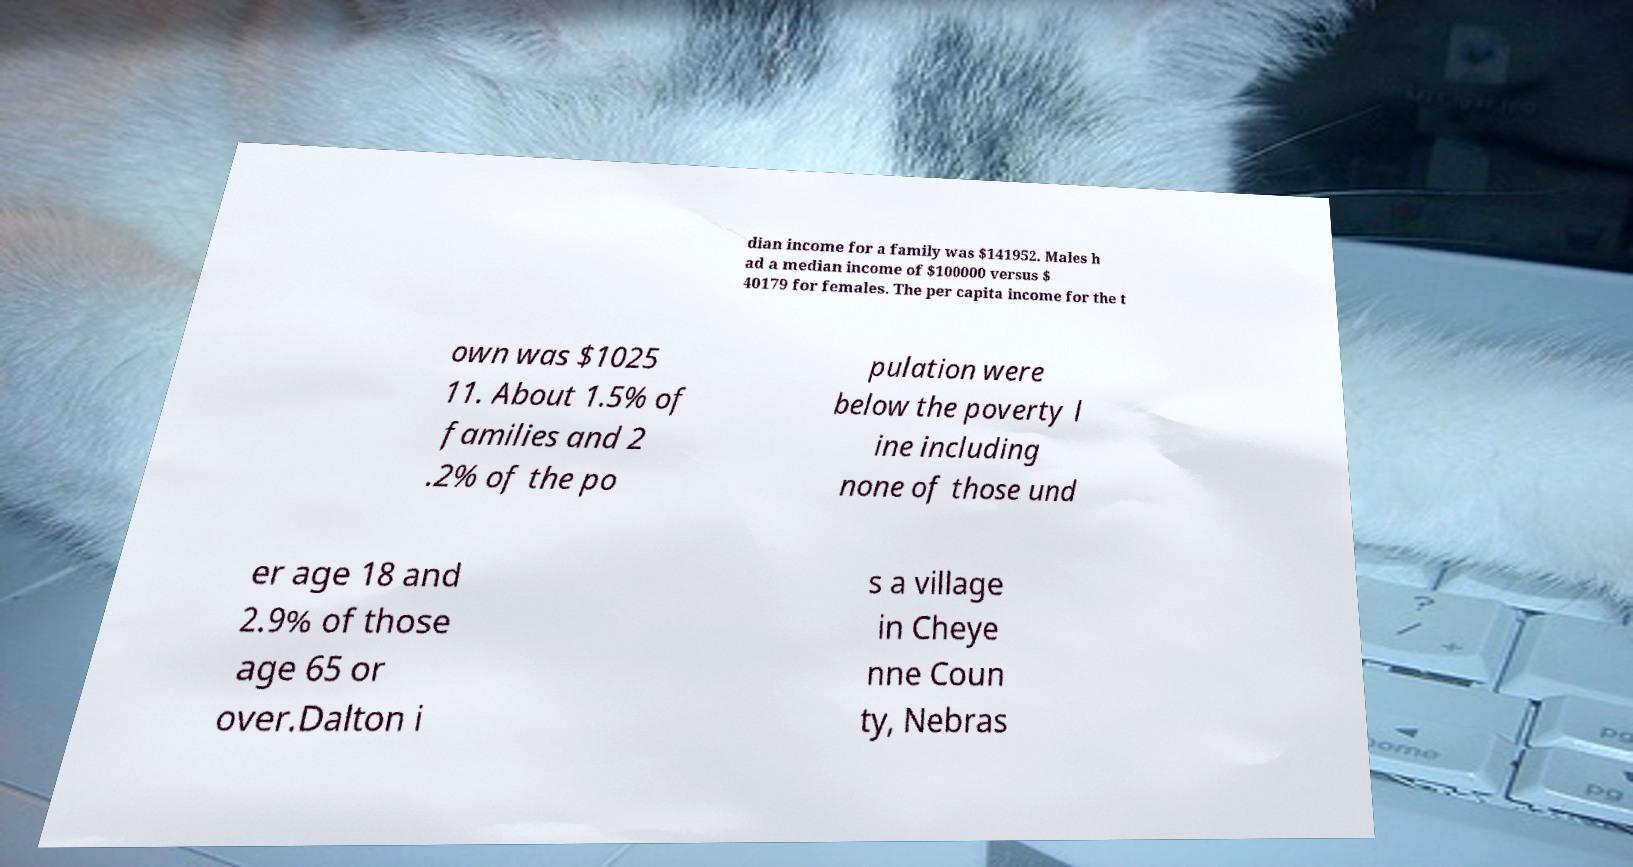Please read and relay the text visible in this image. What does it say? dian income for a family was $141952. Males h ad a median income of $100000 versus $ 40179 for females. The per capita income for the t own was $1025 11. About 1.5% of families and 2 .2% of the po pulation were below the poverty l ine including none of those und er age 18 and 2.9% of those age 65 or over.Dalton i s a village in Cheye nne Coun ty, Nebras 